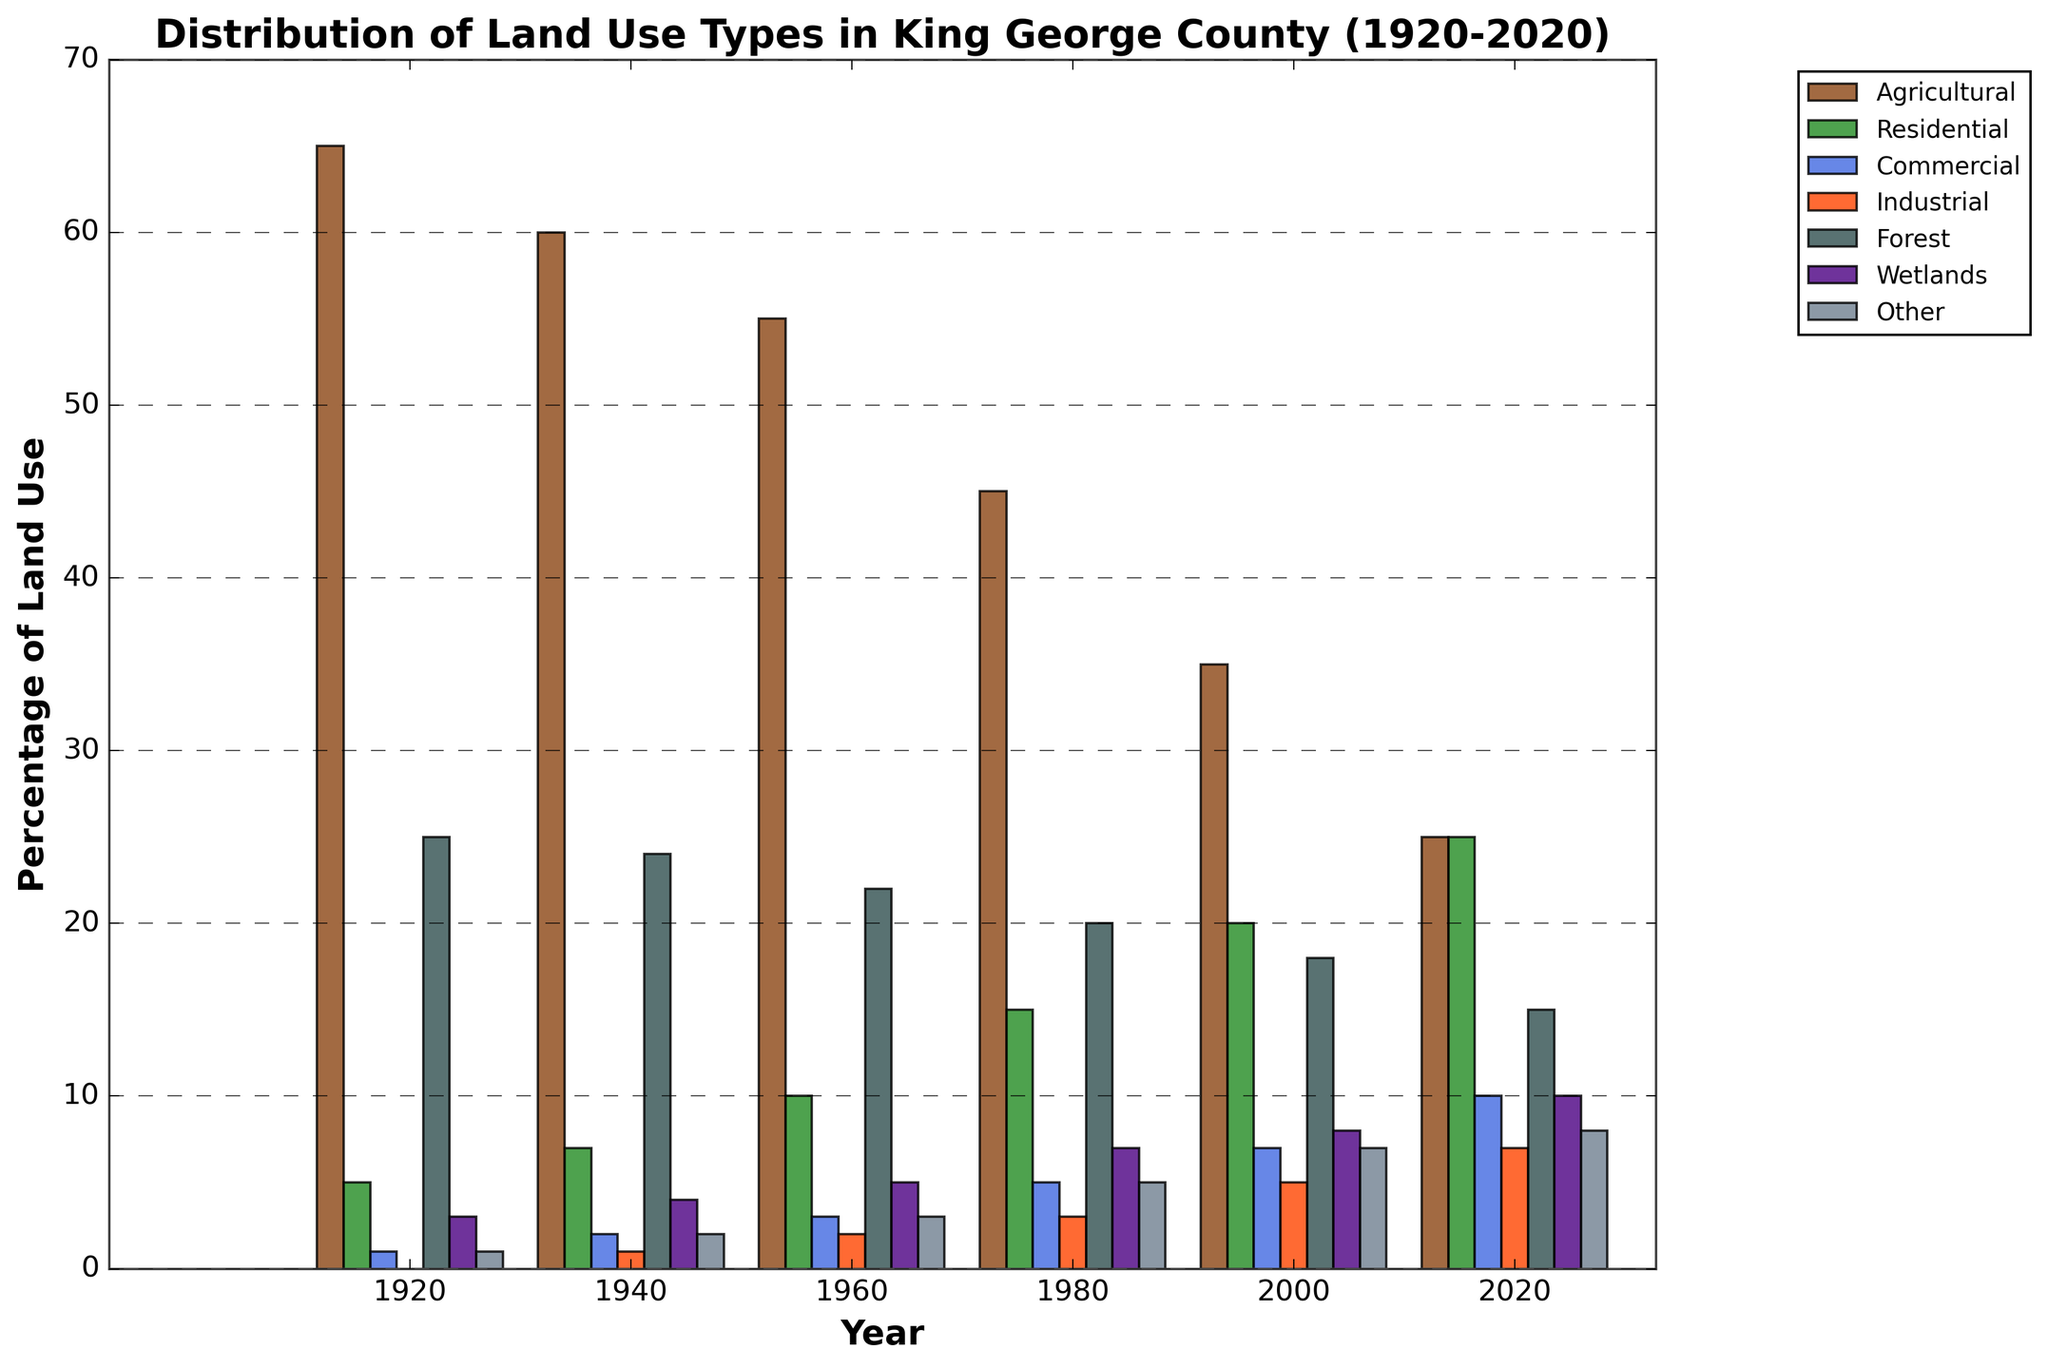What is the percentage of Agricultural land use in 2020? Locate the bar for Agricultural land use. Find the year 2020 along the x-axis and read the corresponding bar height. The Agricultural bar height for 2020 is 25%.
Answer: 25% How did Residential land use change from 1940 to 1960? Locate the Residential bars for 1940 and 1960. Residential land use in 1940 is 7%, and it increased to 10% in 1960. Thus, the increase is 10% - 7% = 3%.
Answer: Increased by 3% Which land use type has the highest percentage in 2000? For the year 2000, compare the heights of the bars. The Agricultural bar is the highest at 35%, which is the greatest percentage compared to other types.
Answer: Agricultural By how much did the percentage of Forest land use change from 1920 to 2020? Locate the Forest bars for 1920 and 2020. Forest land use in 1920 is 25%, and it reduced to 15% in 2020. Therefore, the change is 25% - 15% = 10%.
Answer: Decreased by 10% What is the combined percentage of Commercial and Industrial land use in 1980? Locate the Commercial and Industrial bars for 1980. Commercial land use is 5%, and Industrial land use is 3%. The combined percentage is 5% + 3% = 8%.
Answer: 8% Which land use type shows the most noticeable increase between 1920 and 2020? Compare all land use types for 1920 and 2020. Residential land use increased from 5% in 1920 to 25% in 2020. The increase is 20%, which is the largest among all types.
Answer: Residential In which year did Wetlands reach their highest percentage, and what was that percentage? Compare the Wetlands bars across all years. The highest Wetlands percentage is seen in 2020 at 10%.
Answer: 2020 at 10% How many land use types reached or exceeded 10% in the year 2020? Inspect the bars for 2020 and count the land use types with percentages >= 10%. There are four: Residential (25%), Agricultural (25%), Forest (15%), and Wetlands (10%).
Answer: Four Which two land use types had the closest percentages in 1940, and what were those percentages? Compare the land use types in 1940. Industrial and Commercial had similar percentages, with Industrial at 1% and Commercial at 2%. The difference is 1%.
Answer: Industrial (1%) and Commercial (2%) What was the average percentage of 'Other' land use from 1920 to 2020? Locate the 'Other' land use data for all given years(1, 2, 3, 5, 7, 8). Sum these values: 1 + 2 + 3 + 5 + 7 + 8 = 26. Then divide by the number of years (6): 26 / 6 ≈ 4.33%.
Answer: Approximately 4.33% 